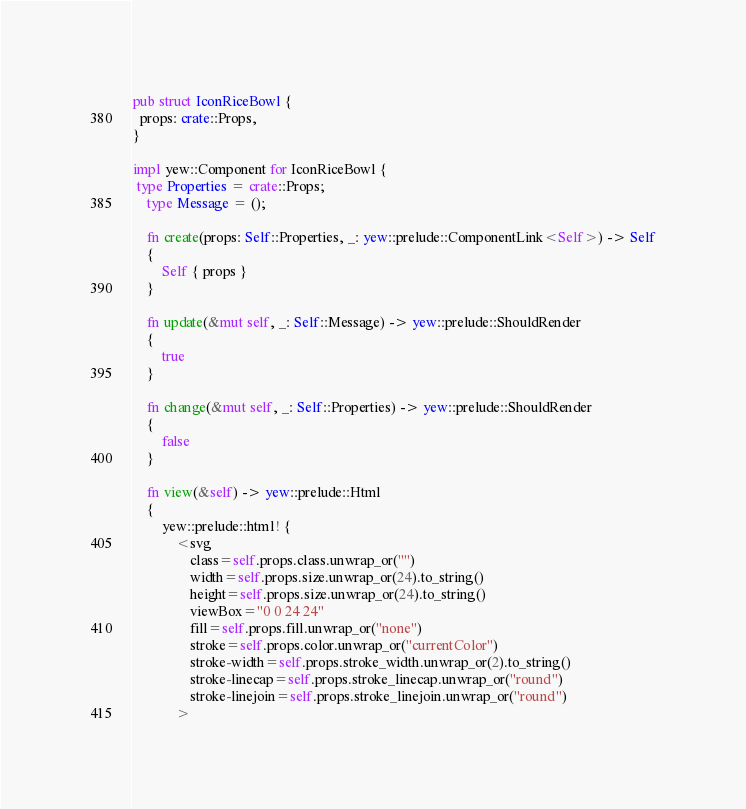Convert code to text. <code><loc_0><loc_0><loc_500><loc_500><_Rust_>
pub struct IconRiceBowl {
  props: crate::Props,
}

impl yew::Component for IconRiceBowl {
 type Properties = crate::Props;
    type Message = ();

    fn create(props: Self::Properties, _: yew::prelude::ComponentLink<Self>) -> Self
    {
        Self { props }
    }

    fn update(&mut self, _: Self::Message) -> yew::prelude::ShouldRender
    {
        true
    }

    fn change(&mut self, _: Self::Properties) -> yew::prelude::ShouldRender
    {
        false
    }

    fn view(&self) -> yew::prelude::Html
    {
        yew::prelude::html! {
            <svg
                class=self.props.class.unwrap_or("")
                width=self.props.size.unwrap_or(24).to_string()
                height=self.props.size.unwrap_or(24).to_string()
                viewBox="0 0 24 24"
                fill=self.props.fill.unwrap_or("none")
                stroke=self.props.color.unwrap_or("currentColor")
                stroke-width=self.props.stroke_width.unwrap_or(2).to_string()
                stroke-linecap=self.props.stroke_linecap.unwrap_or("round")
                stroke-linejoin=self.props.stroke_linejoin.unwrap_or("round")
            ></code> 